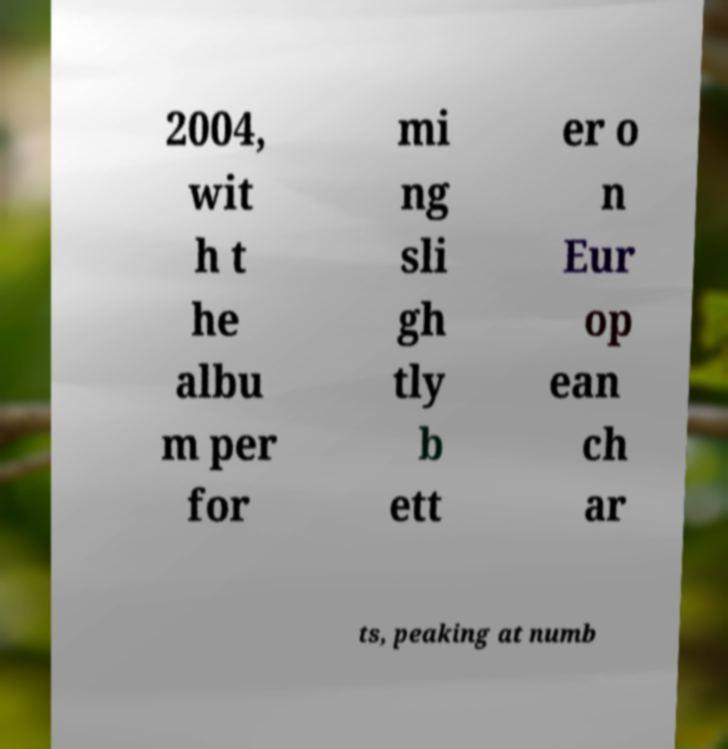I need the written content from this picture converted into text. Can you do that? 2004, wit h t he albu m per for mi ng sli gh tly b ett er o n Eur op ean ch ar ts, peaking at numb 